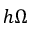<formula> <loc_0><loc_0><loc_500><loc_500>h \Omega</formula> 